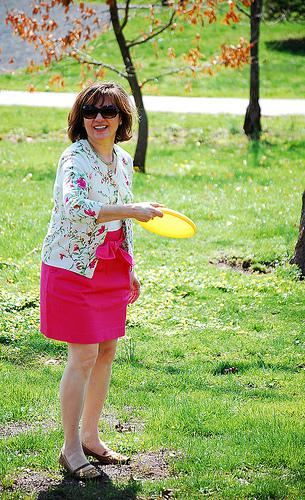Question: why does the lady have her arm up?
Choices:
A. To hail a cab.
B. To throw the frisbee.
C. To wave at a friend.
D. To reach a high shelf.
Answer with the letter. Answer: B Question: what color is the lady's skirt?
Choices:
A. Pink.
B. Black.
C. Blue.
D. Brown.
Answer with the letter. Answer: A Question: what activity is the person taking part in?
Choices:
A. Golf.
B. Frisbee.
C. Baseball.
D. Basketball.
Answer with the letter. Answer: B Question: where does this image take place?
Choices:
A. In the park.
B. At a house.
C. In a mall.
D. At a pool.
Answer with the letter. Answer: A 